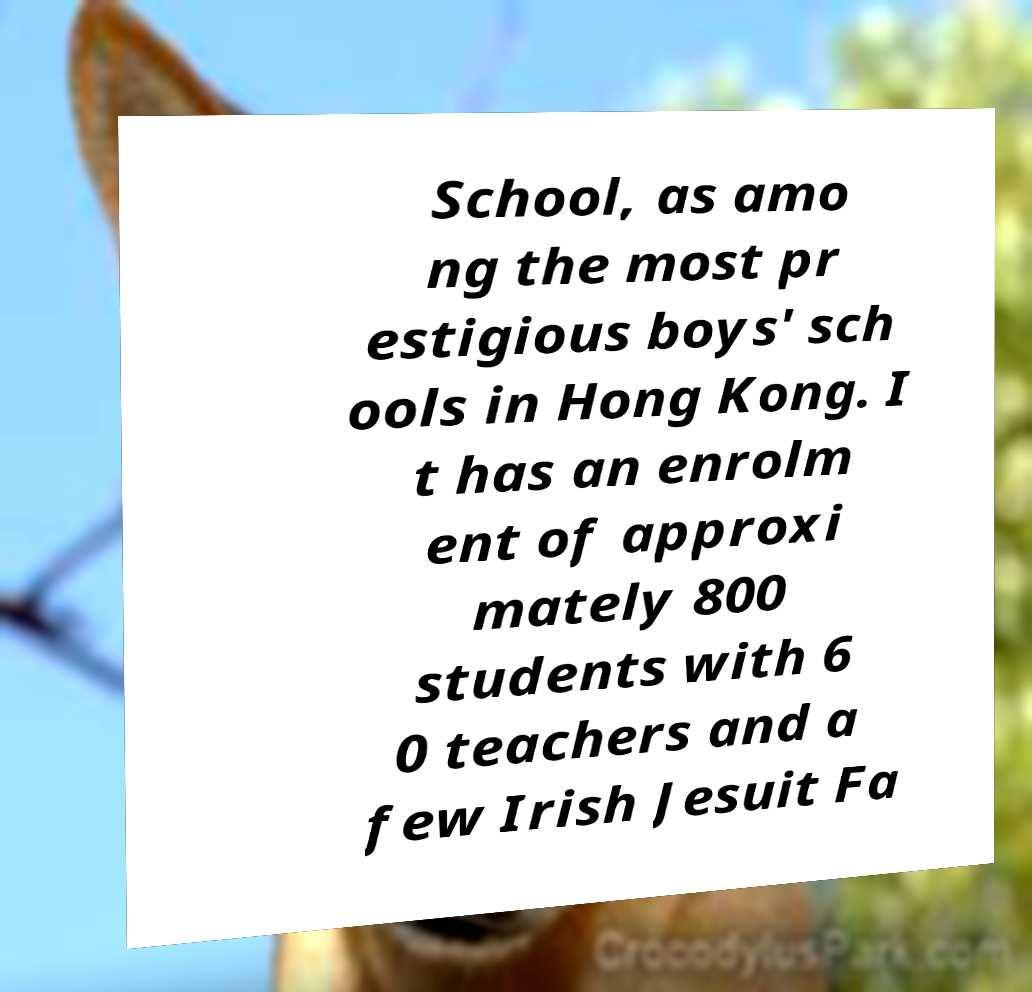Could you assist in decoding the text presented in this image and type it out clearly? School, as amo ng the most pr estigious boys' sch ools in Hong Kong. I t has an enrolm ent of approxi mately 800 students with 6 0 teachers and a few Irish Jesuit Fa 